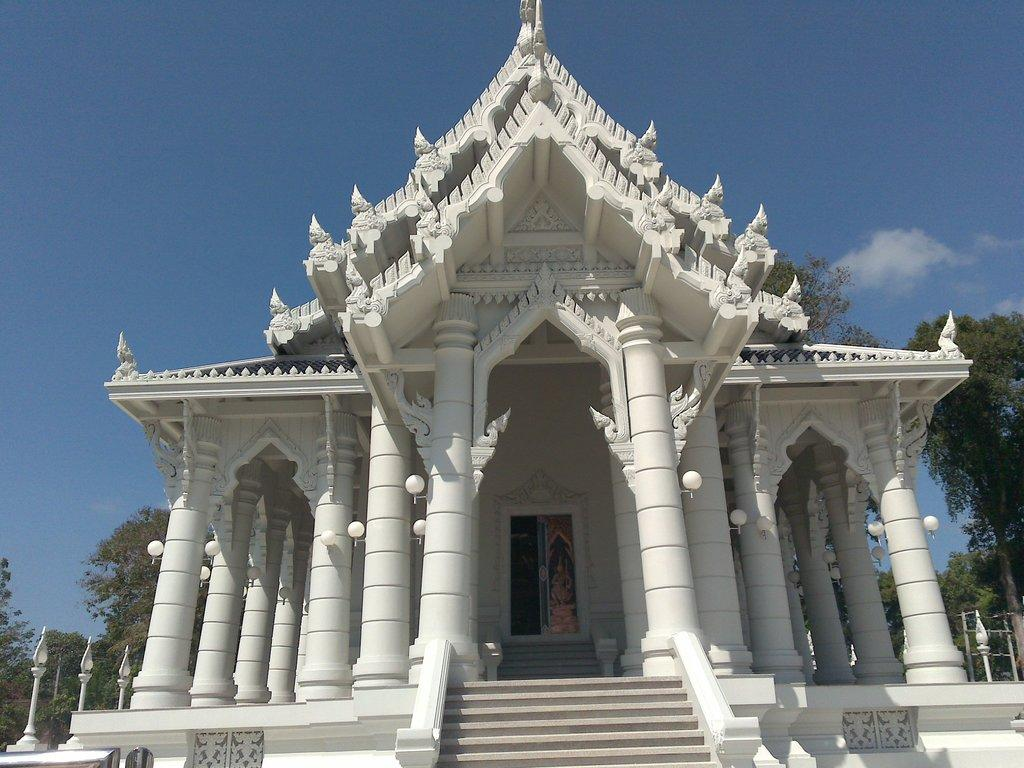What is the main structure in the center of the image? There is a building in the center of the image. What architectural feature is present in the center of the image? There is a staircase and pillars in the center of the image. What can be seen in the background of the image? There are trees and poles in the background of the image. What is visible at the top of the image? The sky is visible at the top of the image. What type of dog can be seen receiving a shock from the building in the image? There is no dog present in the image, and no shock is depicted. 